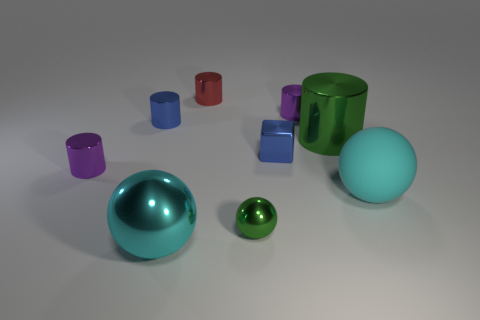Subtract all purple metal cylinders. How many cylinders are left? 3 Subtract all red cylinders. How many cylinders are left? 4 Add 1 tiny blue objects. How many objects exist? 10 Subtract all spheres. How many objects are left? 6 Subtract all cyan cylinders. Subtract all red blocks. How many cylinders are left? 5 Subtract 0 brown blocks. How many objects are left? 9 Subtract all small blue cylinders. Subtract all small green metallic spheres. How many objects are left? 7 Add 4 metallic blocks. How many metallic blocks are left? 5 Add 2 big purple shiny objects. How many big purple shiny objects exist? 2 